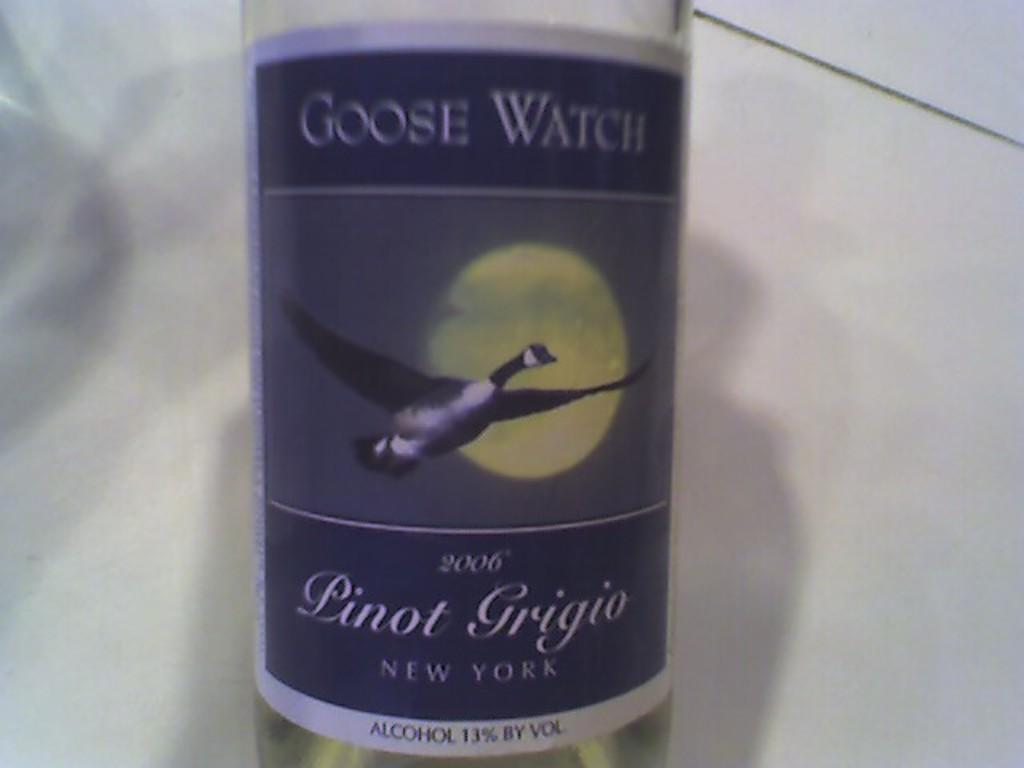Provide a one-sentence caption for the provided image. A bottle of Linot Grigio New York alcohol. 